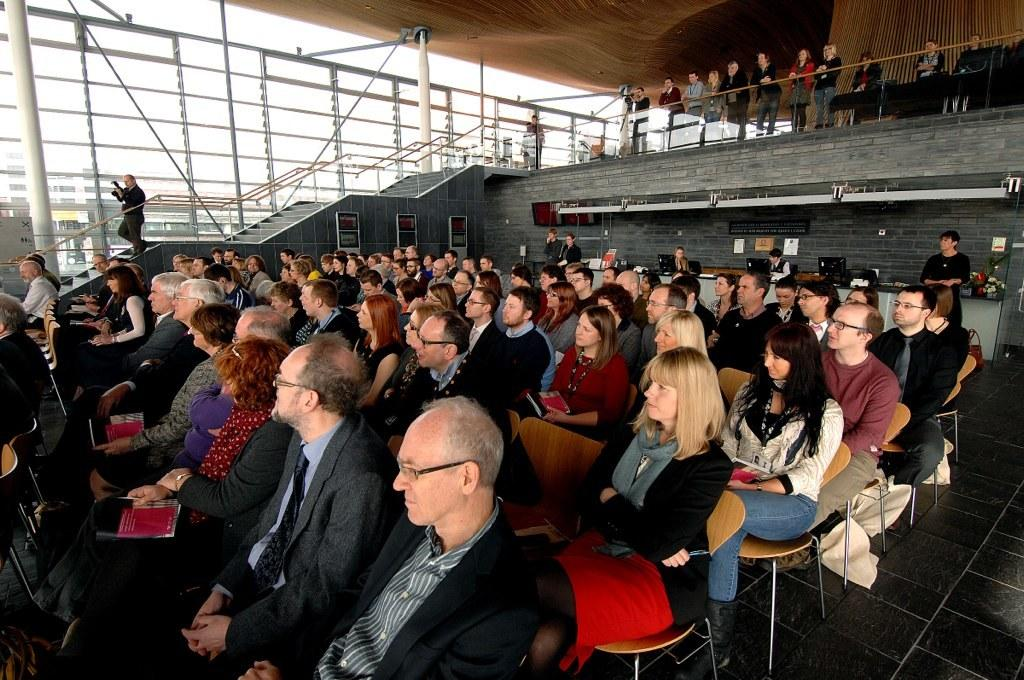What is the main activity of the people in the image? The main activity of the people in the image is sitting on chairs. What can be seen on the left side of the image? There are stairs on the left side of the image. Where are some people located in relation to the stairs? There are people standing at the top of the image. What are these people at the top doing? These people at the top are watching the people at the bottom. What type of mint plant can be seen growing on the stairs in the image? There is no mint plant visible on the stairs in the image. How many cups are being used by the people sitting on chairs in the image? There is no mention of cups in the image; the main focus is on the people sitting on chairs and the stairs. 